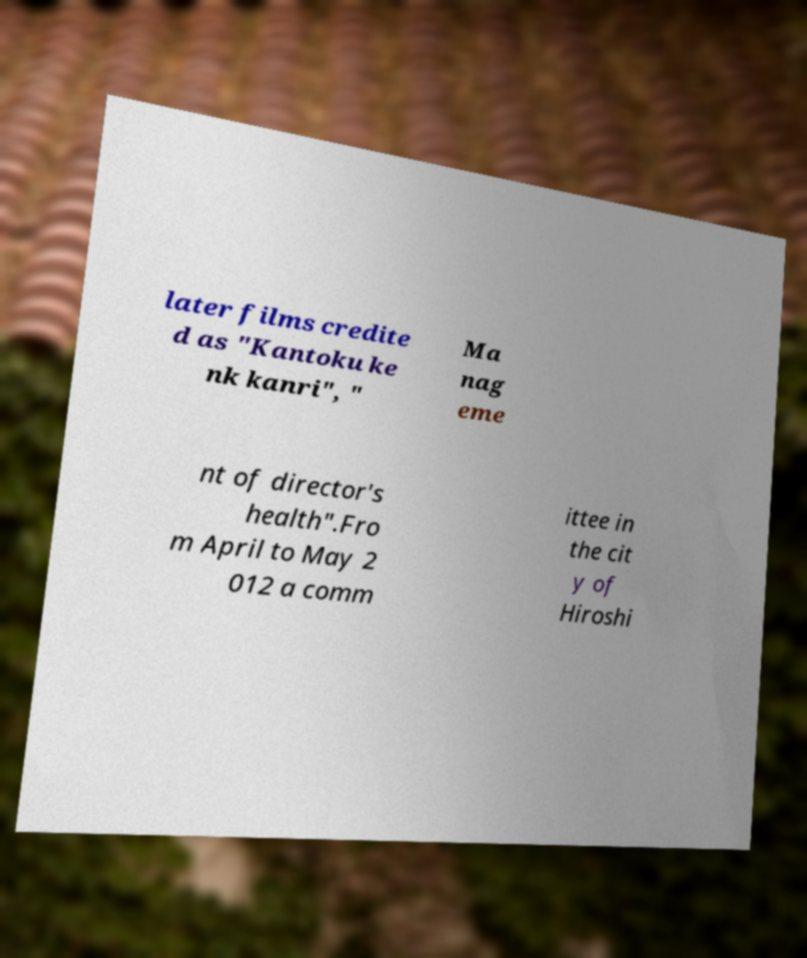Please identify and transcribe the text found in this image. later films credite d as "Kantoku ke nk kanri", " Ma nag eme nt of director's health".Fro m April to May 2 012 a comm ittee in the cit y of Hiroshi 